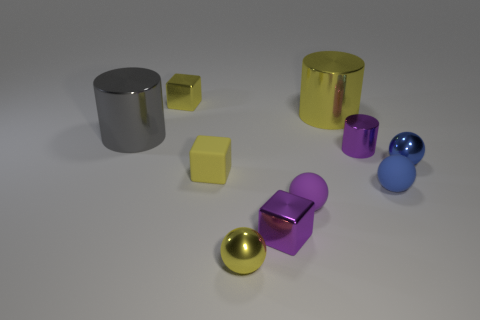Subtract all cylinders. How many objects are left? 7 Subtract all tiny metal spheres. Subtract all small blue objects. How many objects are left? 6 Add 5 purple matte balls. How many purple matte balls are left? 6 Add 7 tiny purple shiny cylinders. How many tiny purple shiny cylinders exist? 8 Subtract 0 red blocks. How many objects are left? 10 